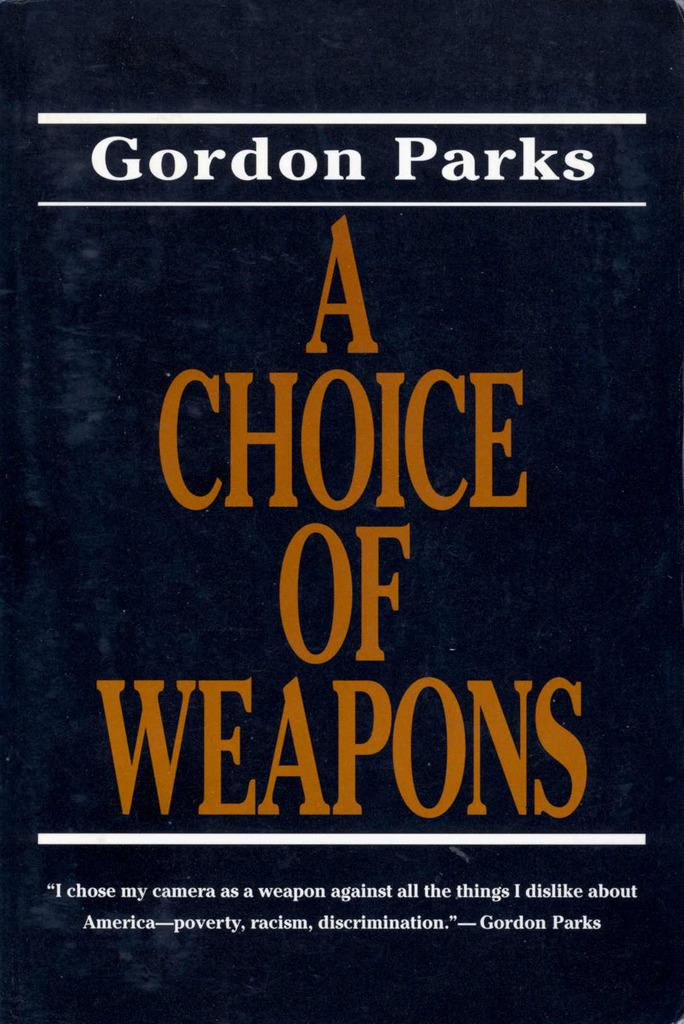<image>
Write a terse but informative summary of the picture. The book shown is written by the author Gordon Parks. 